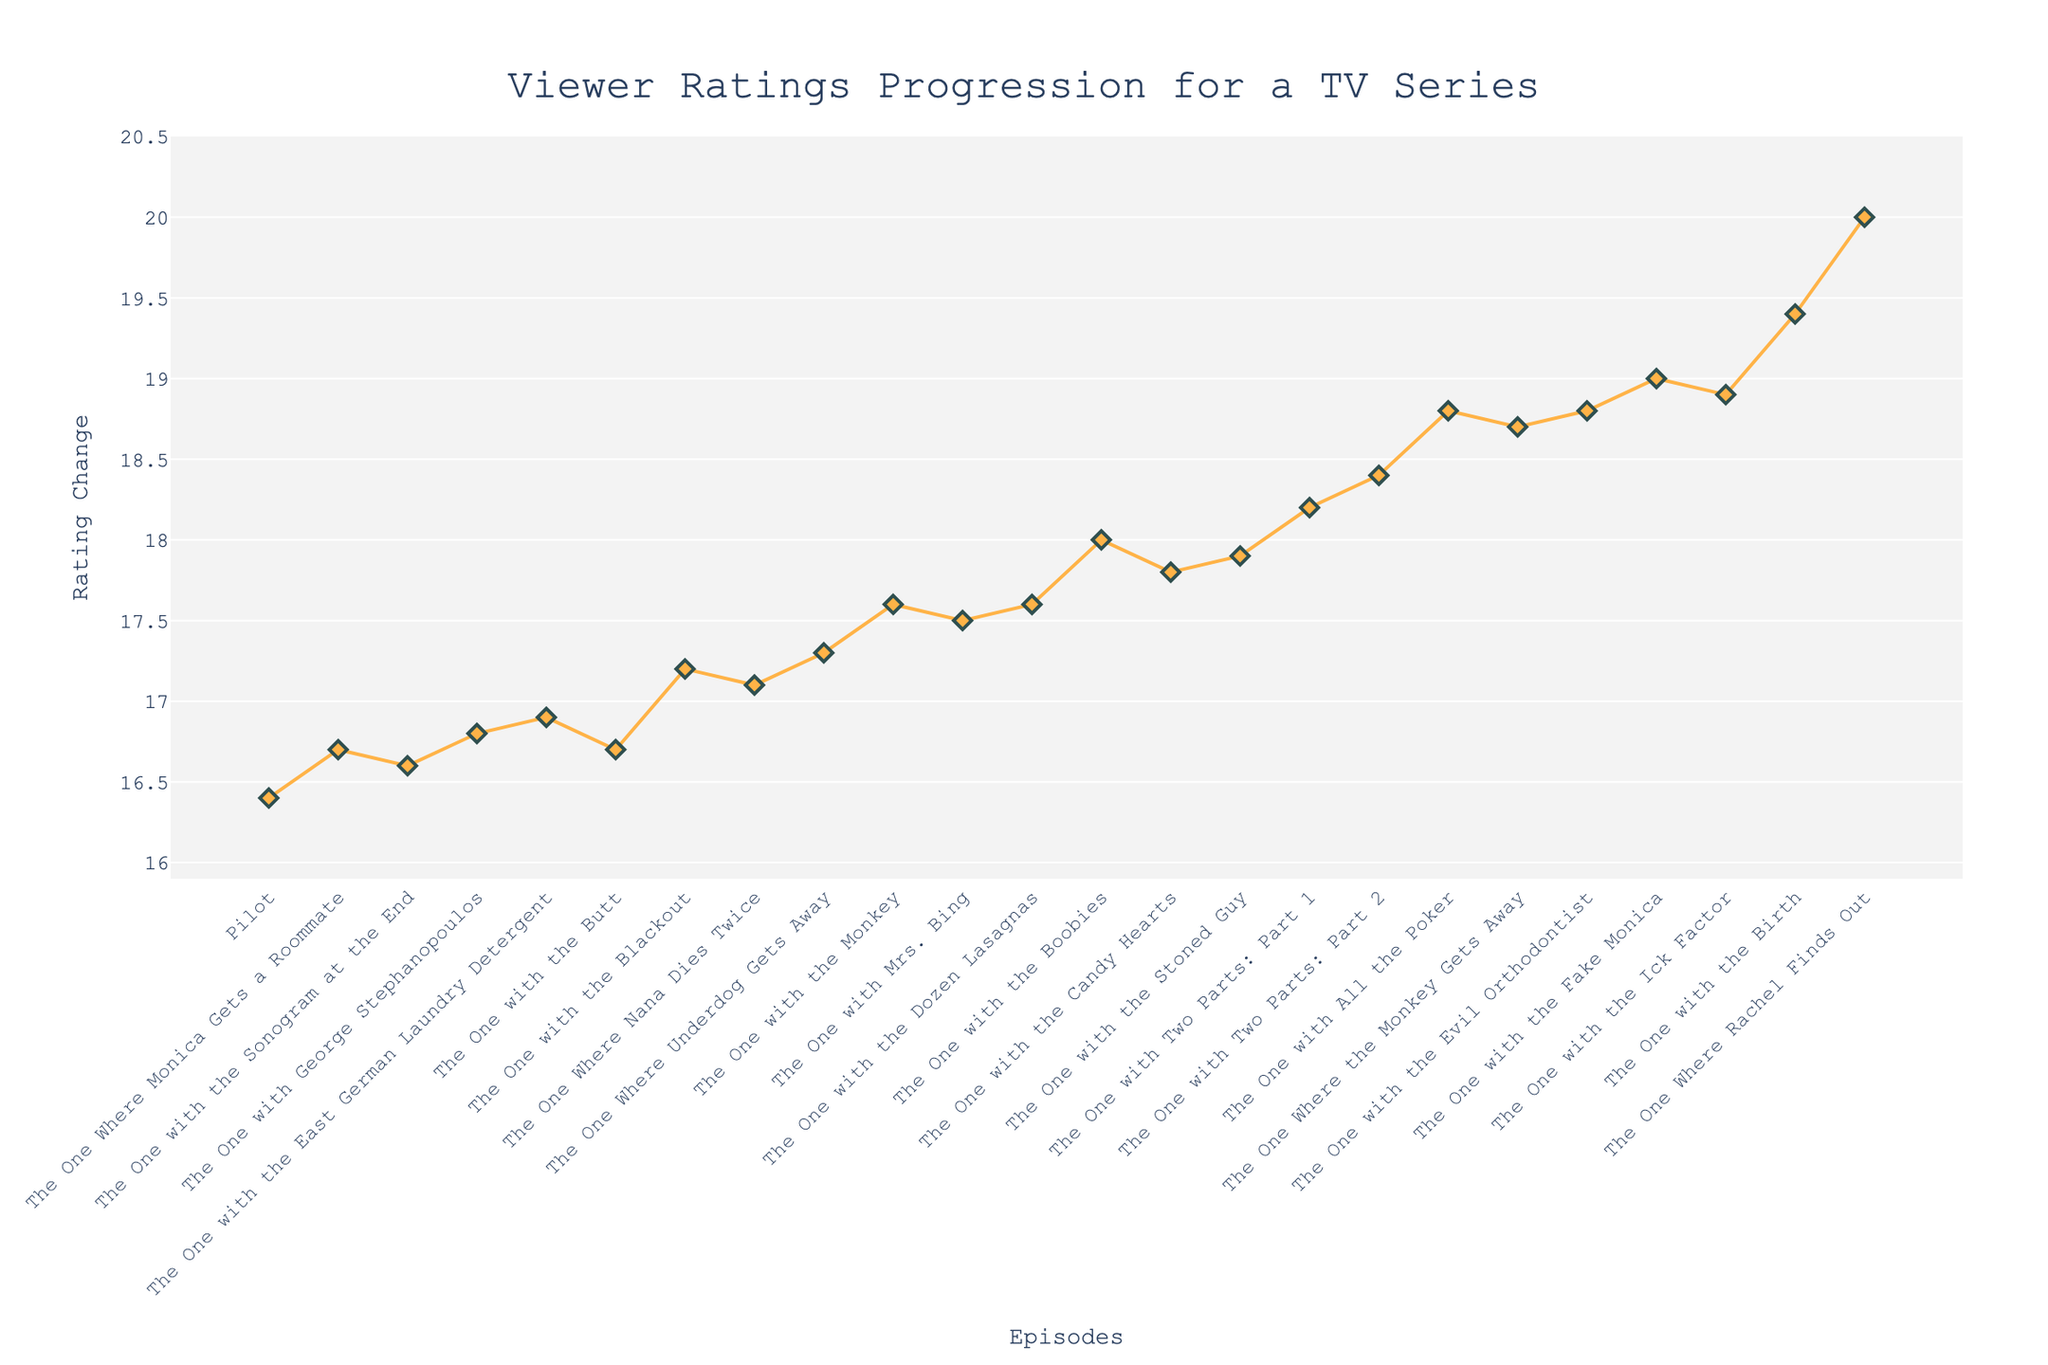what is the initial rating in the first episode, "Pilot"? The initial rating is explicitly mentioned next to the "Pilot" entry on the chart. It is 8.2, as shown at the start of the cumulative line and the first bar of the chart.
Answer: 8.2 How many episodes had a negative rating change? By counting the bars that descend (colored differently, in pinkish tones), you can see there are four episodes: "The One with the Sonogram at the End," "The One with the Butt," "The One Where Nana Dies Twice," and "The One with the Candy Hearts."
Answer: 4 Between which episodes did the largest single increase in ratings occur? Observing the height of the positive bars, "The One Where Rachel Finds Out" had the largest increase, which is 0.6.
Answer: "The One Where Rachel Finds Out" Which episode had the cumulative rating closest to 9? By looking at the cumulative line, the episode "The One with the Monkey" has its cumulative plot point very close to 9.
Answer: "The One with the Monkey" How many episodes had a rating change greater than or equal to 0.4? Count the number of bars with a height of 0.4 or higher. Episodes "The One with the Blackout," "The One with the Boobies," "The One with All the Poker," "The One with the Birth," and "The One Where Rachel Finds Out" all have rating changes of at least 0.4.
Answer: 5 What is the overall trend in ratings across the episodes? By observing the direction of the cumulative line, you can see that overall, the trend is positive, as the cumulative ratings generally increase from the start to the end of the series.
Answer: Positive Between which episodes did the cumulative rating surpass 9.5 for the first time? Follow the cumulative line and check when it crosses 9.5. The cumulative rating first surpasses 9.5 between "The One with the Ick Factor" and "The One with the Birth."
Answer: Between "The One with the Ick Factor" and "The One with the Birth" How much did the rating change by the end of the series? By summing up all the rating changes from "The One Where Monica Gets a Roommate" to "The One Where Rachel Finds Out," you can calculate the total change. The total is 8.2 (initial) + summation of rating changes = 13.6. So, the rating changed by + 5.4 points.
Answer: 5.4 points What color is used to indicate episodes with increasing ratings? You can identify from the color legend that increasing ratings are represented with a light green color.
Answer: Light green 